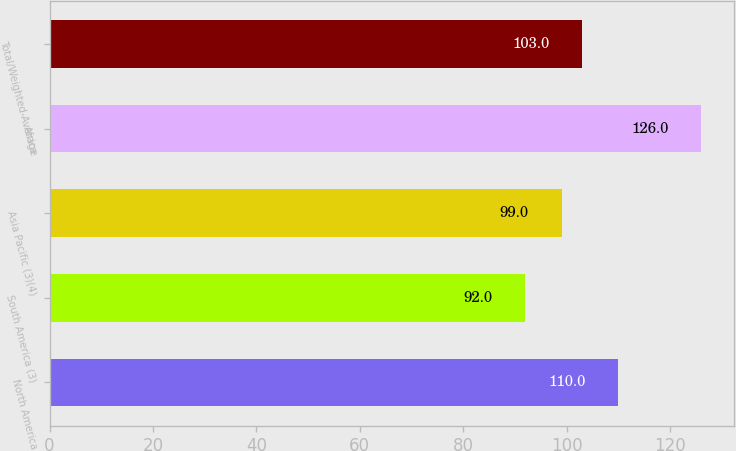Convert chart. <chart><loc_0><loc_0><loc_500><loc_500><bar_chart><fcel>North America<fcel>South America (3)<fcel>Asia Pacific (3)(4)<fcel>Africa<fcel>Total/Weighted-Average<nl><fcel>110<fcel>92<fcel>99<fcel>126<fcel>103<nl></chart> 